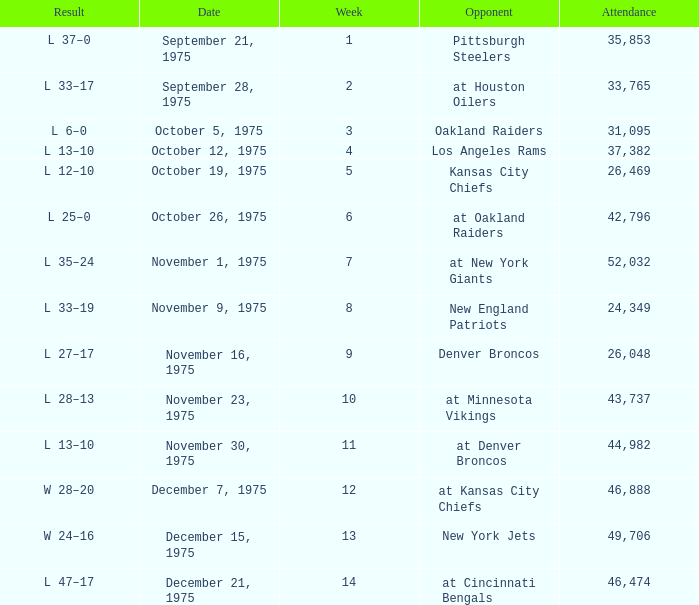What is the lowest Week when the result was l 13–10, November 30, 1975, with more than 44,982 people in attendance? None. Parse the table in full. {'header': ['Result', 'Date', 'Week', 'Opponent', 'Attendance'], 'rows': [['L 37–0', 'September 21, 1975', '1', 'Pittsburgh Steelers', '35,853'], ['L 33–17', 'September 28, 1975', '2', 'at Houston Oilers', '33,765'], ['L 6–0', 'October 5, 1975', '3', 'Oakland Raiders', '31,095'], ['L 13–10', 'October 12, 1975', '4', 'Los Angeles Rams', '37,382'], ['L 12–10', 'October 19, 1975', '5', 'Kansas City Chiefs', '26,469'], ['L 25–0', 'October 26, 1975', '6', 'at Oakland Raiders', '42,796'], ['L 35–24', 'November 1, 1975', '7', 'at New York Giants', '52,032'], ['L 33–19', 'November 9, 1975', '8', 'New England Patriots', '24,349'], ['L 27–17', 'November 16, 1975', '9', 'Denver Broncos', '26,048'], ['L 28–13', 'November 23, 1975', '10', 'at Minnesota Vikings', '43,737'], ['L 13–10', 'November 30, 1975', '11', 'at Denver Broncos', '44,982'], ['W 28–20', 'December 7, 1975', '12', 'at Kansas City Chiefs', '46,888'], ['W 24–16', 'December 15, 1975', '13', 'New York Jets', '49,706'], ['L 47–17', 'December 21, 1975', '14', 'at Cincinnati Bengals', '46,474']]} 